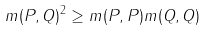Convert formula to latex. <formula><loc_0><loc_0><loc_500><loc_500>m ( P , Q ) ^ { 2 } \geq m ( P , P ) m ( Q , Q )</formula> 